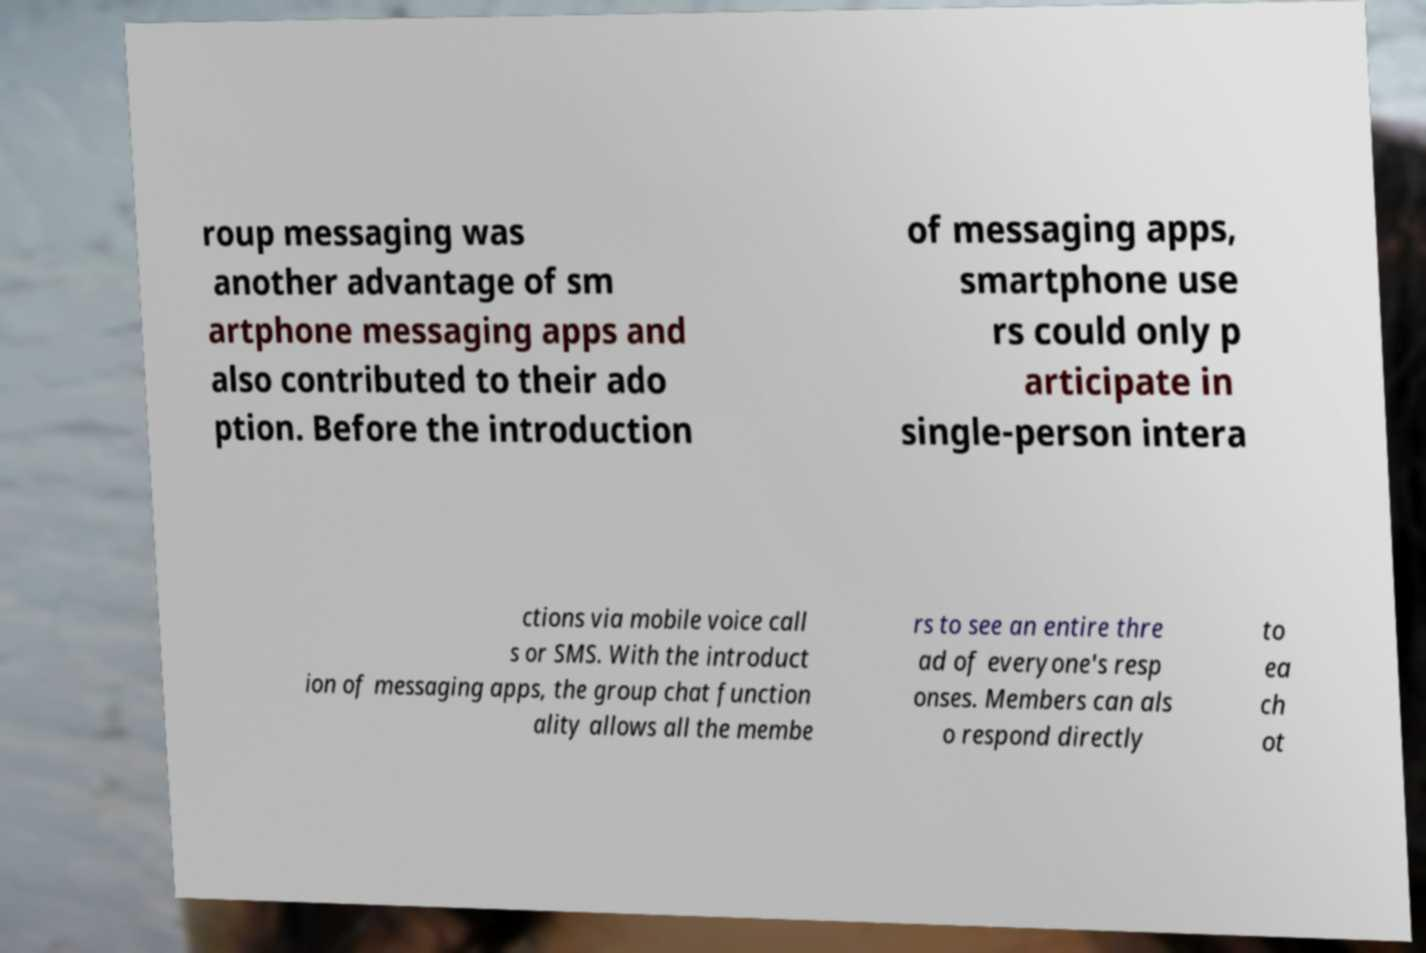Please read and relay the text visible in this image. What does it say? roup messaging was another advantage of sm artphone messaging apps and also contributed to their ado ption. Before the introduction of messaging apps, smartphone use rs could only p articipate in single-person intera ctions via mobile voice call s or SMS. With the introduct ion of messaging apps, the group chat function ality allows all the membe rs to see an entire thre ad of everyone's resp onses. Members can als o respond directly to ea ch ot 